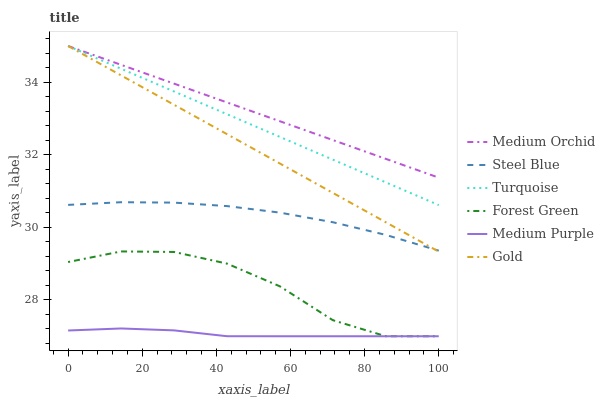Does Medium Purple have the minimum area under the curve?
Answer yes or no. Yes. Does Medium Orchid have the maximum area under the curve?
Answer yes or no. Yes. Does Gold have the minimum area under the curve?
Answer yes or no. No. Does Gold have the maximum area under the curve?
Answer yes or no. No. Is Gold the smoothest?
Answer yes or no. Yes. Is Forest Green the roughest?
Answer yes or no. Yes. Is Medium Orchid the smoothest?
Answer yes or no. No. Is Medium Orchid the roughest?
Answer yes or no. No. Does Medium Purple have the lowest value?
Answer yes or no. Yes. Does Gold have the lowest value?
Answer yes or no. No. Does Medium Orchid have the highest value?
Answer yes or no. Yes. Does Steel Blue have the highest value?
Answer yes or no. No. Is Medium Purple less than Turquoise?
Answer yes or no. Yes. Is Gold greater than Forest Green?
Answer yes or no. Yes. Does Medium Orchid intersect Gold?
Answer yes or no. Yes. Is Medium Orchid less than Gold?
Answer yes or no. No. Is Medium Orchid greater than Gold?
Answer yes or no. No. Does Medium Purple intersect Turquoise?
Answer yes or no. No. 